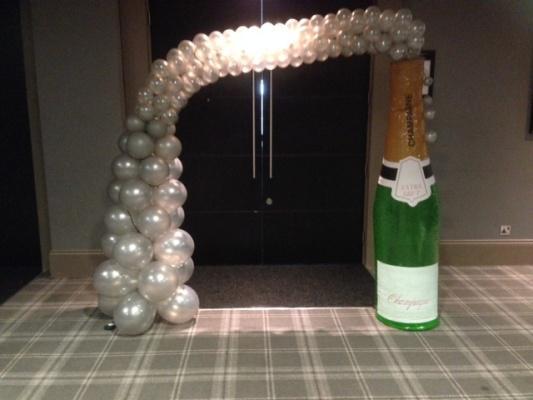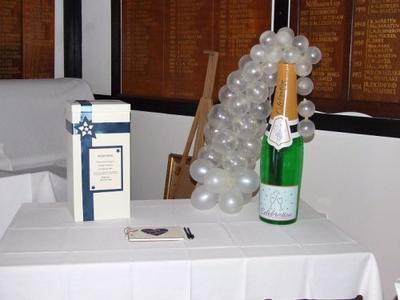The first image is the image on the left, the second image is the image on the right. Given the left and right images, does the statement "There is a white arch of balloons that attached to a big bottle that is over an entrance door." hold true? Answer yes or no. Yes. The first image is the image on the left, the second image is the image on the right. For the images displayed, is the sentence "A bottle is on the right side of a door." factually correct? Answer yes or no. Yes. 